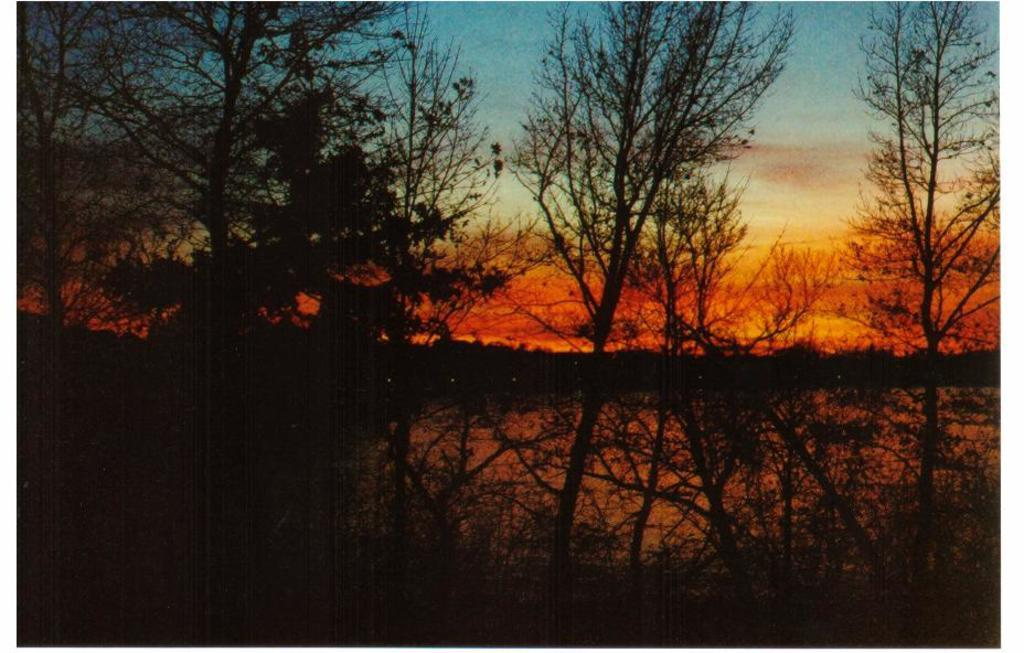What type of vegetation can be seen in the image? There are trees in the image. What type of terrain is visible in the image? There are hills visible in the image. What part of the natural environment is visible in the image? The sky is visible in the image. What is the condition of the sky in the image? Clouds are present in the sky. What type of linen is draped over the trees in the image? There is no linen present in the image; it features trees, hills, and a sky with clouds. How many toes can be seen on the hills in the image? There are no toes visible in the image, as it features natural elements like trees, hills, and clouds. 